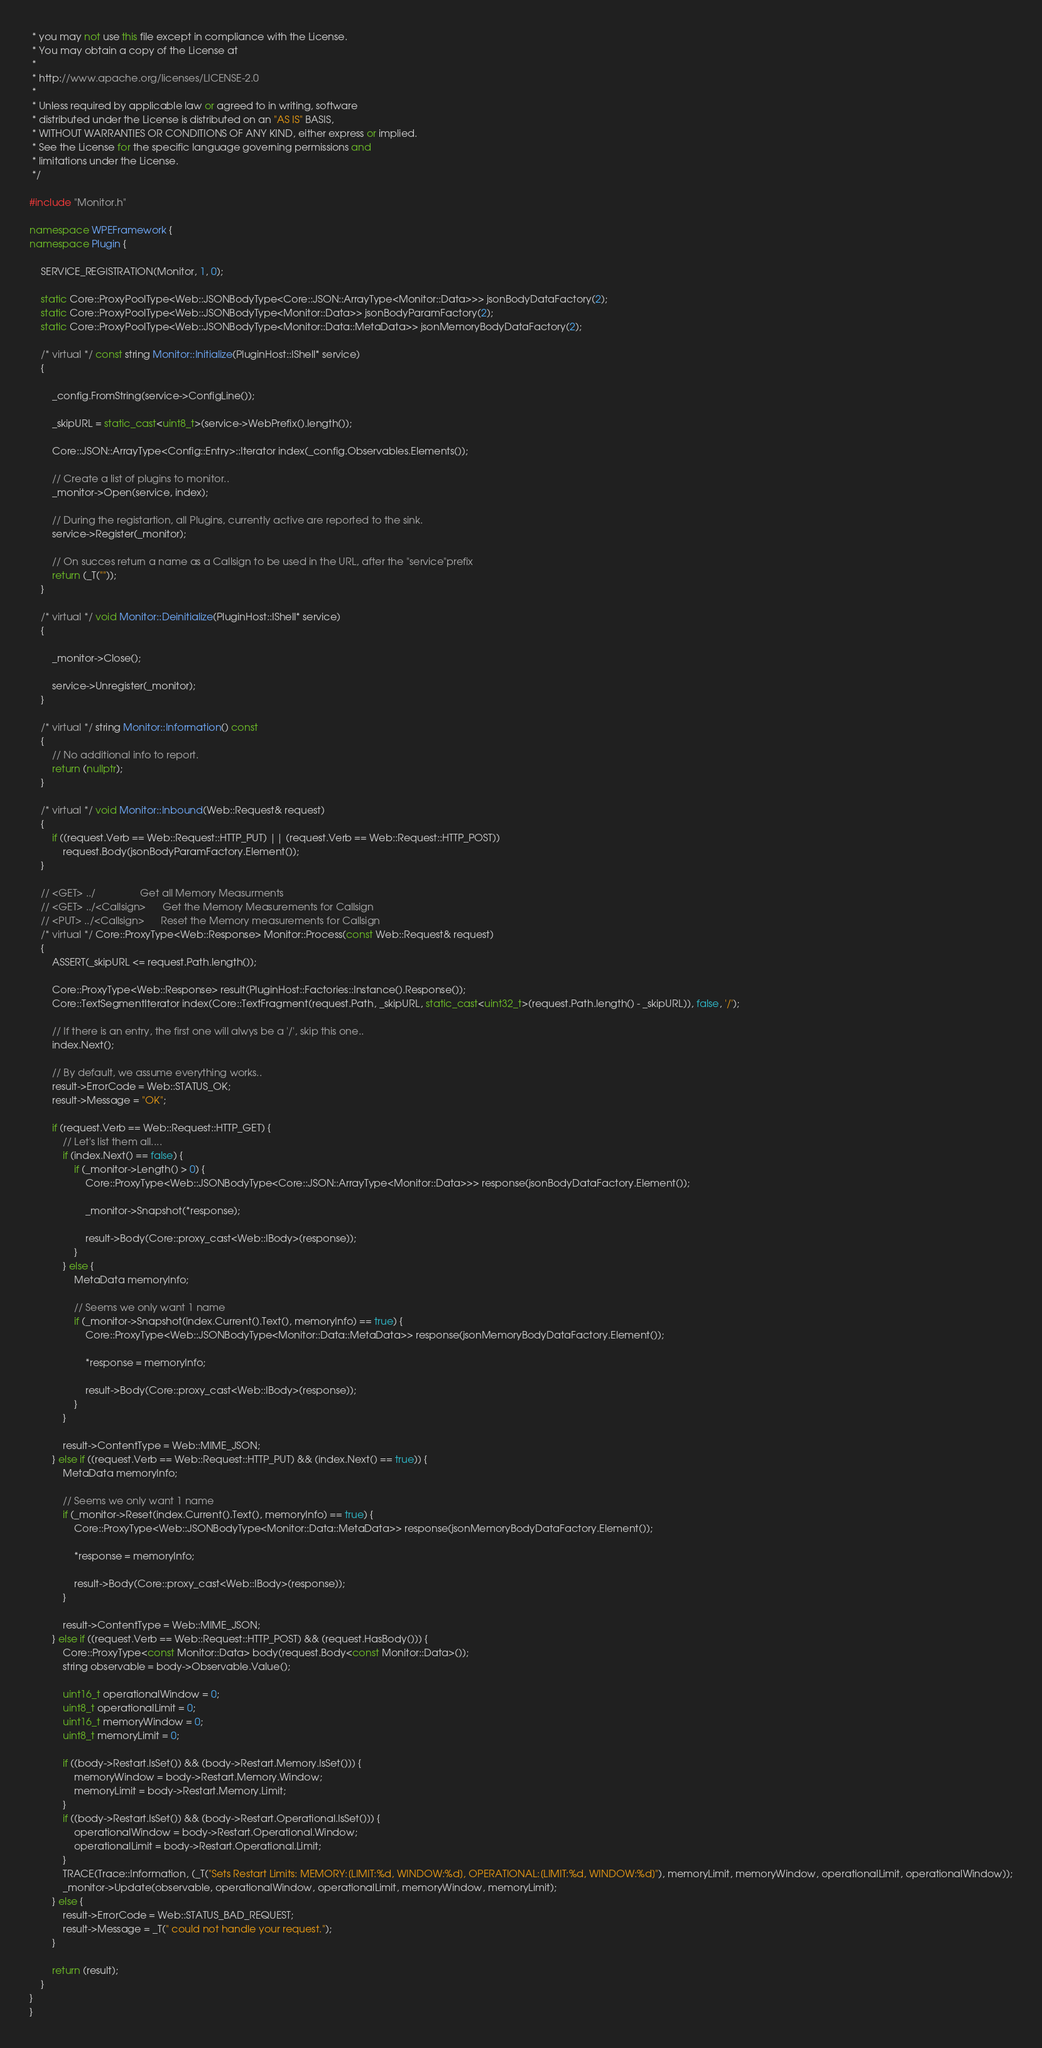Convert code to text. <code><loc_0><loc_0><loc_500><loc_500><_C++_> * you may not use this file except in compliance with the License.
 * You may obtain a copy of the License at
 *
 * http://www.apache.org/licenses/LICENSE-2.0
 *
 * Unless required by applicable law or agreed to in writing, software
 * distributed under the License is distributed on an "AS IS" BASIS,
 * WITHOUT WARRANTIES OR CONDITIONS OF ANY KIND, either express or implied.
 * See the License for the specific language governing permissions and
 * limitations under the License.
 */
 
#include "Monitor.h"

namespace WPEFramework {
namespace Plugin {

    SERVICE_REGISTRATION(Monitor, 1, 0);

    static Core::ProxyPoolType<Web::JSONBodyType<Core::JSON::ArrayType<Monitor::Data>>> jsonBodyDataFactory(2);
    static Core::ProxyPoolType<Web::JSONBodyType<Monitor::Data>> jsonBodyParamFactory(2);
    static Core::ProxyPoolType<Web::JSONBodyType<Monitor::Data::MetaData>> jsonMemoryBodyDataFactory(2);

    /* virtual */ const string Monitor::Initialize(PluginHost::IShell* service)
    {

        _config.FromString(service->ConfigLine());

        _skipURL = static_cast<uint8_t>(service->WebPrefix().length());

        Core::JSON::ArrayType<Config::Entry>::Iterator index(_config.Observables.Elements());

        // Create a list of plugins to monitor..
        _monitor->Open(service, index);

        // During the registartion, all Plugins, currently active are reported to the sink.
        service->Register(_monitor);

        // On succes return a name as a Callsign to be used in the URL, after the "service"prefix
        return (_T(""));
    }

    /* virtual */ void Monitor::Deinitialize(PluginHost::IShell* service)
    {

        _monitor->Close();

        service->Unregister(_monitor);
    }

    /* virtual */ string Monitor::Information() const
    {
        // No additional info to report.
        return (nullptr);
    }

    /* virtual */ void Monitor::Inbound(Web::Request& request)
    {
        if ((request.Verb == Web::Request::HTTP_PUT) || (request.Verb == Web::Request::HTTP_POST))
            request.Body(jsonBodyParamFactory.Element());
    }

    // <GET> ../				Get all Memory Measurments
    // <GET> ../<Callsign>		Get the Memory Measurements for Callsign
    // <PUT> ../<Callsign>		Reset the Memory measurements for Callsign
    /* virtual */ Core::ProxyType<Web::Response> Monitor::Process(const Web::Request& request)
    {
        ASSERT(_skipURL <= request.Path.length());

        Core::ProxyType<Web::Response> result(PluginHost::Factories::Instance().Response());
        Core::TextSegmentIterator index(Core::TextFragment(request.Path, _skipURL, static_cast<uint32_t>(request.Path.length() - _skipURL)), false, '/');

        // If there is an entry, the first one will alwys be a '/', skip this one..
        index.Next();

        // By default, we assume everything works..
        result->ErrorCode = Web::STATUS_OK;
        result->Message = "OK";

        if (request.Verb == Web::Request::HTTP_GET) {
            // Let's list them all....
            if (index.Next() == false) {
                if (_monitor->Length() > 0) {
                    Core::ProxyType<Web::JSONBodyType<Core::JSON::ArrayType<Monitor::Data>>> response(jsonBodyDataFactory.Element());

                    _monitor->Snapshot(*response);

                    result->Body(Core::proxy_cast<Web::IBody>(response));
                }
            } else {
                MetaData memoryInfo;

                // Seems we only want 1 name
                if (_monitor->Snapshot(index.Current().Text(), memoryInfo) == true) {
                    Core::ProxyType<Web::JSONBodyType<Monitor::Data::MetaData>> response(jsonMemoryBodyDataFactory.Element());

                    *response = memoryInfo;

                    result->Body(Core::proxy_cast<Web::IBody>(response));
                }
            }

            result->ContentType = Web::MIME_JSON;
        } else if ((request.Verb == Web::Request::HTTP_PUT) && (index.Next() == true)) {
            MetaData memoryInfo;

            // Seems we only want 1 name
            if (_monitor->Reset(index.Current().Text(), memoryInfo) == true) {
                Core::ProxyType<Web::JSONBodyType<Monitor::Data::MetaData>> response(jsonMemoryBodyDataFactory.Element());

                *response = memoryInfo;

                result->Body(Core::proxy_cast<Web::IBody>(response));
            }

            result->ContentType = Web::MIME_JSON;
        } else if ((request.Verb == Web::Request::HTTP_POST) && (request.HasBody())) {
            Core::ProxyType<const Monitor::Data> body(request.Body<const Monitor::Data>());
            string observable = body->Observable.Value();

			uint16_t operationalWindow = 0;
            uint8_t operationalLimit = 0;
            uint16_t memoryWindow = 0;
            uint8_t memoryLimit = 0;

            if ((body->Restart.IsSet()) && (body->Restart.Memory.IsSet())) {
                memoryWindow = body->Restart.Memory.Window;
                memoryLimit = body->Restart.Memory.Limit;
            }
            if ((body->Restart.IsSet()) && (body->Restart.Operational.IsSet())) {
                operationalWindow = body->Restart.Operational.Window;
                operationalLimit = body->Restart.Operational.Limit;
            }
            TRACE(Trace::Information, (_T("Sets Restart Limits: MEMORY:[LIMIT:%d, WINDOW:%d], OPERATIONAL:[LIMIT:%d, WINDOW:%d]"), memoryLimit, memoryWindow, operationalLimit, operationalWindow));
            _monitor->Update(observable, operationalWindow, operationalLimit, memoryWindow, memoryLimit);
        } else {
            result->ErrorCode = Web::STATUS_BAD_REQUEST;
            result->Message = _T(" could not handle your request.");
        }

        return (result);
    }
}
}
</code> 